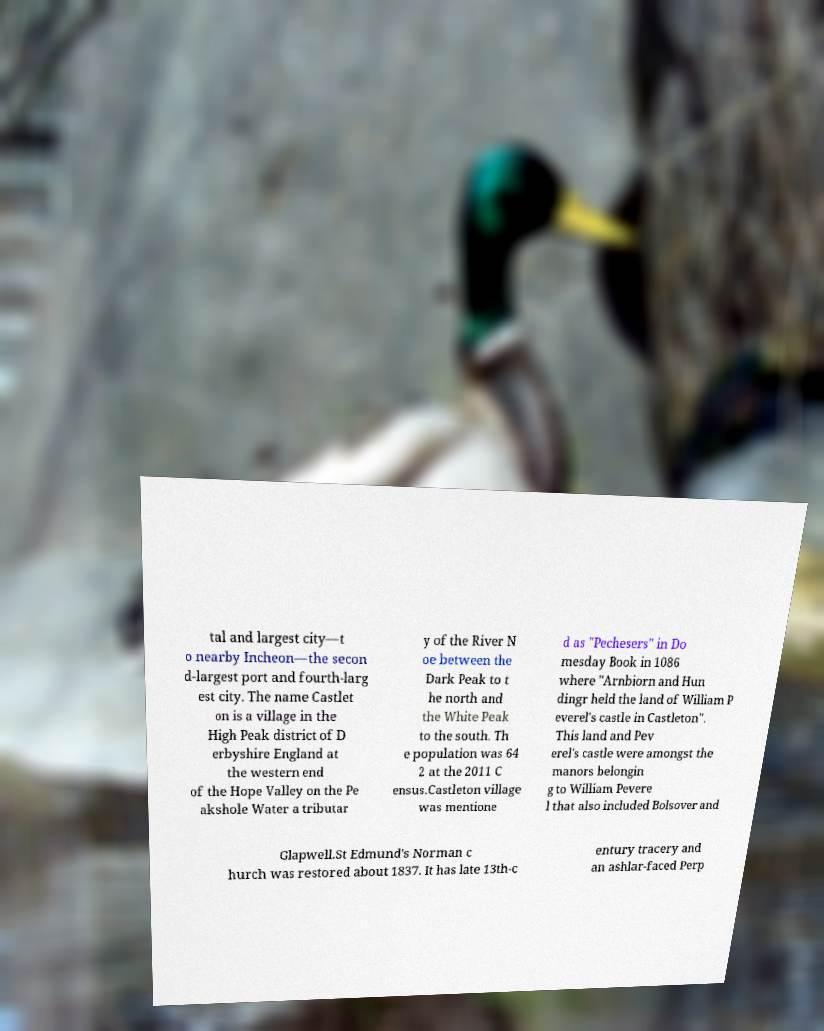Can you read and provide the text displayed in the image?This photo seems to have some interesting text. Can you extract and type it out for me? tal and largest city—t o nearby Incheon—the secon d-largest port and fourth-larg est city. The name Castlet on is a village in the High Peak district of D erbyshire England at the western end of the Hope Valley on the Pe akshole Water a tributar y of the River N oe between the Dark Peak to t he north and the White Peak to the south. Th e population was 64 2 at the 2011 C ensus.Castleton village was mentione d as "Pechesers" in Do mesday Book in 1086 where "Arnbiorn and Hun dingr held the land of William P everel's castle in Castleton". This land and Pev erel's castle were amongst the manors belongin g to William Pevere l that also included Bolsover and Glapwell.St Edmund's Norman c hurch was restored about 1837. It has late 13th-c entury tracery and an ashlar-faced Perp 